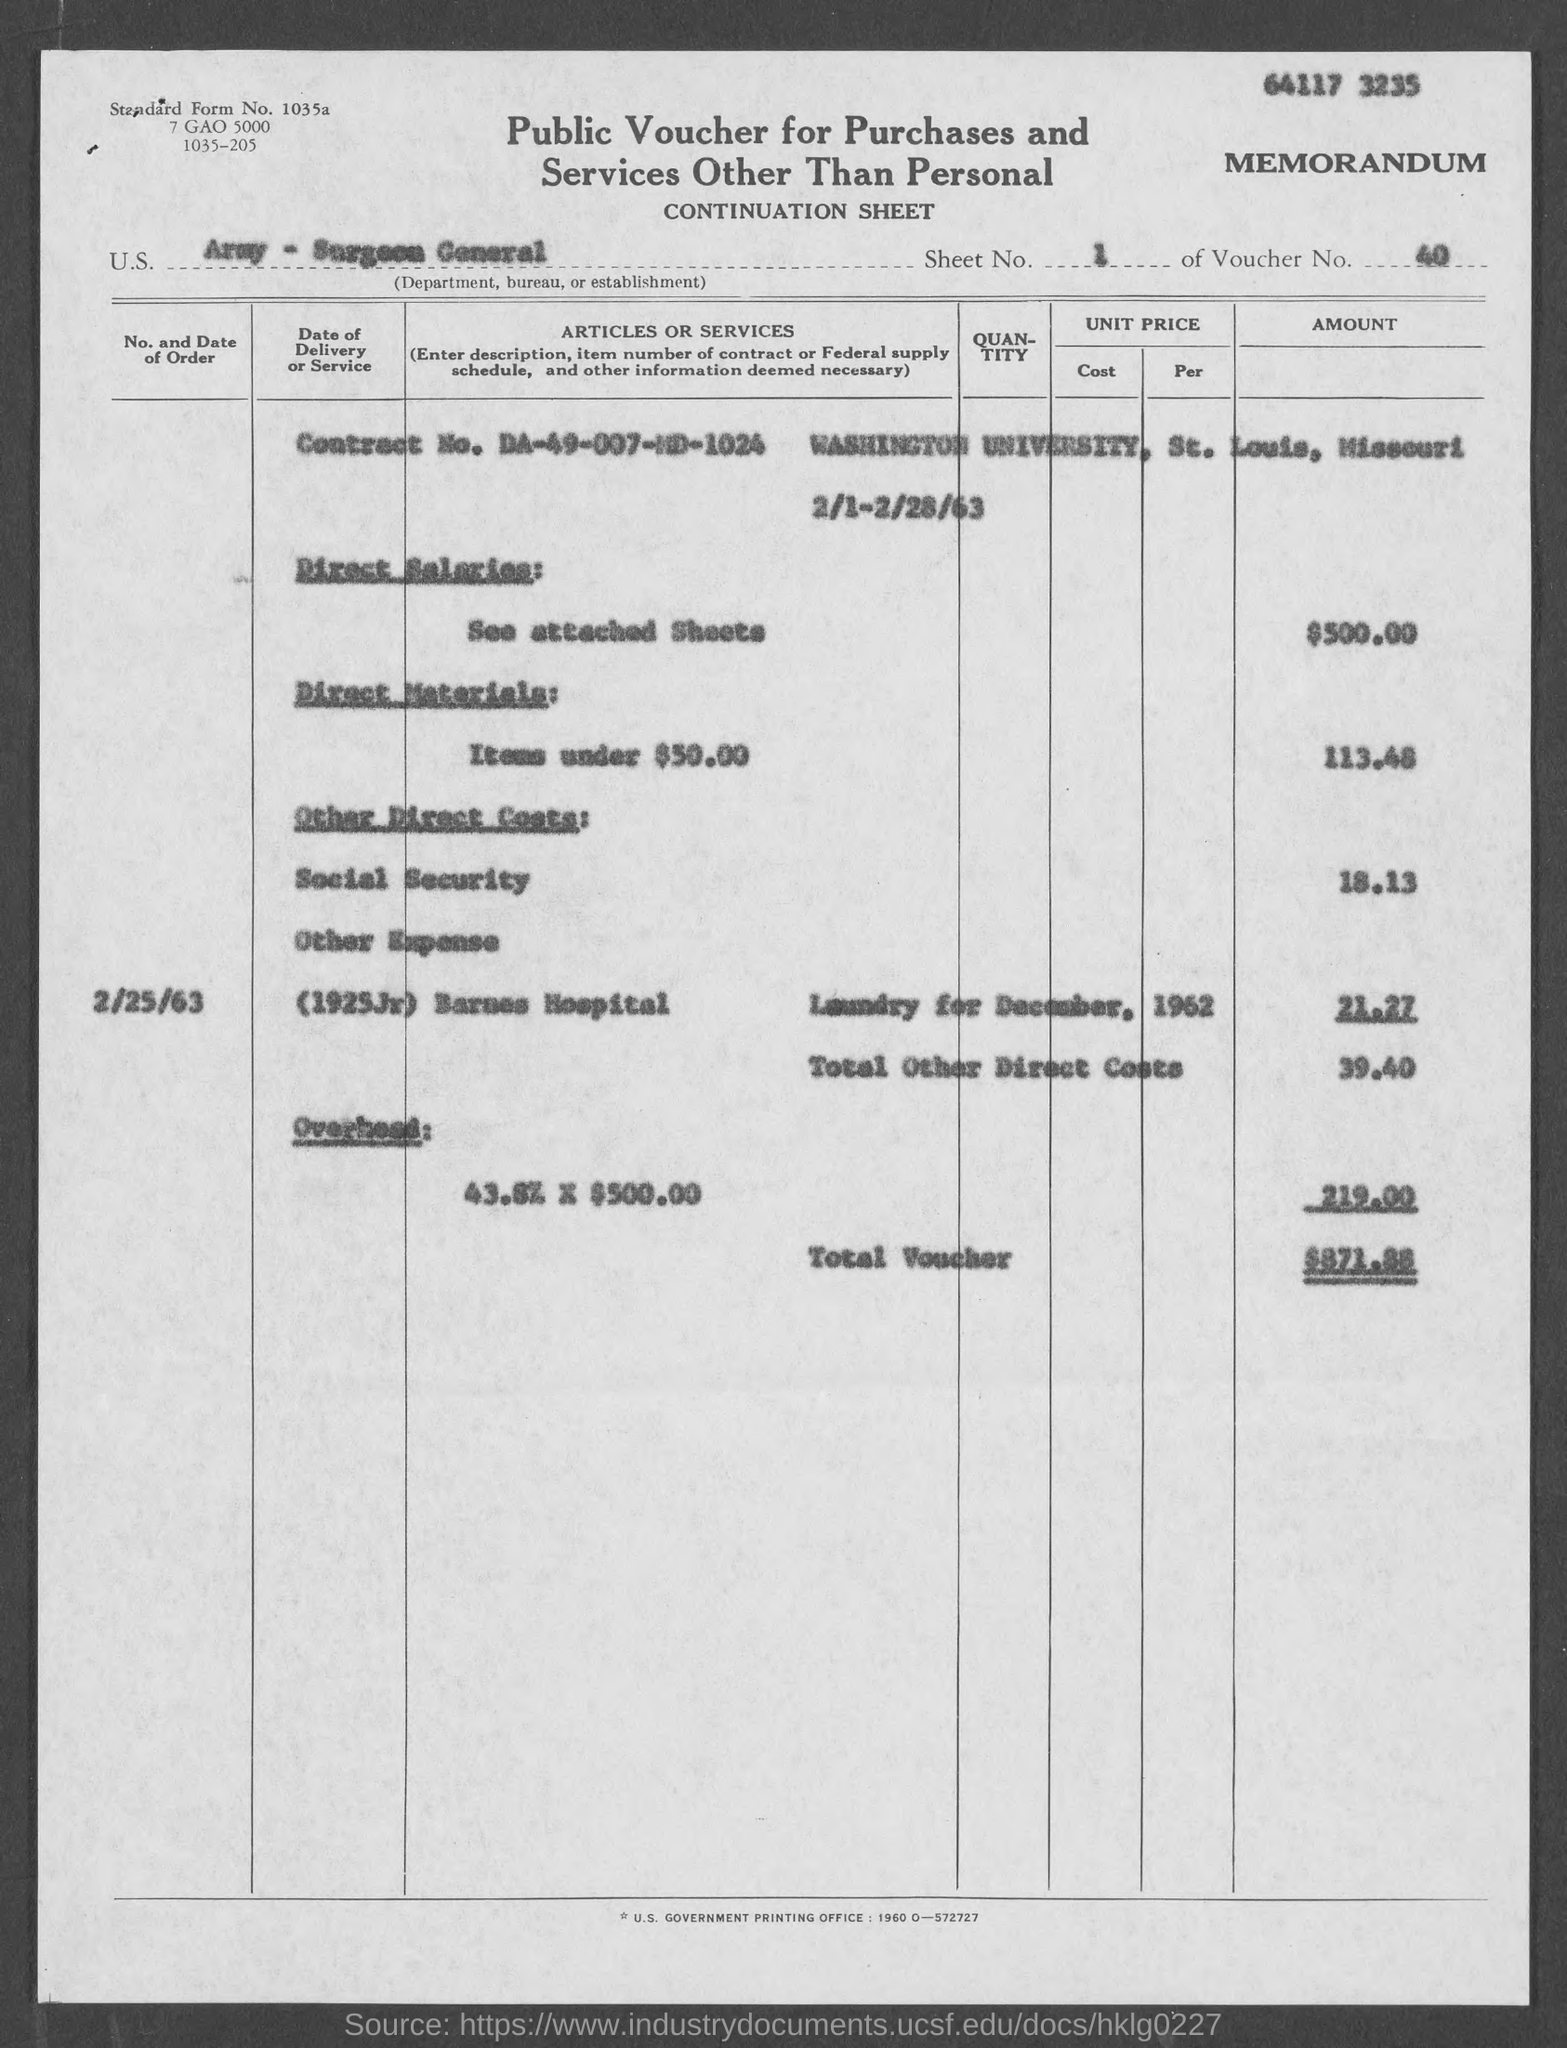What is the standard form no.?
Your answer should be compact. 1035a. What is the sheet no.?
Your response must be concise. 1. What is the voucher no.?
Offer a terse response. 40. What is the contract no.?
Offer a very short reply. DA-49-007-MD-1024. In which state is washington university at?
Make the answer very short. Missouri. What is the total voucher amount ?
Provide a succinct answer. $871.88. 